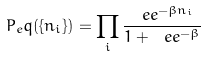<formula> <loc_0><loc_0><loc_500><loc_500>P _ { e } q ( \{ n _ { i } \} ) = \prod _ { i } \frac { \ e e ^ { - \beta n _ { i } } } { 1 + \ e e ^ { - \beta } }</formula> 